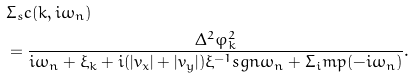Convert formula to latex. <formula><loc_0><loc_0><loc_500><loc_500>& \Sigma _ { s } c ( k , i \omega _ { n } ) \\ & = \frac { \Delta ^ { 2 } \varphi _ { k } ^ { 2 } } { i \omega _ { n } + \xi _ { k } + i ( | v _ { x } | + | v _ { y } | ) \xi ^ { - 1 } s g n \omega _ { n } + \Sigma _ { i } m p ( - i \omega _ { n } ) } .</formula> 